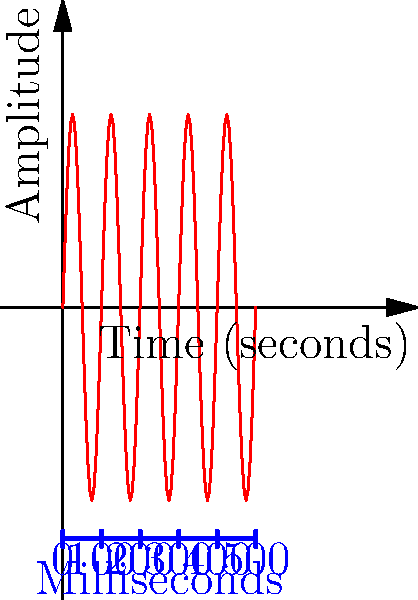As a DJ, you're analyzing a waveform of a new Drake track for your next block party mix. The waveform above represents a 0.5-second snippet of the song. If you count 5 complete cycles in this waveform, what is the beat-per-minute (BPM) of the song? Let's break this down step-by-step:

1) First, we need to calculate the frequency of the waveform:
   - We see 5 complete cycles in 0.5 seconds
   - Frequency = Number of cycles / Time
   - Frequency = 5 / 0.5 = 10 Hz

2) Now, we need to convert this frequency to beats per minute:
   - 1 Hz = 60 BPM (because there are 60 seconds in a minute)
   - So, 10 Hz = 10 * 60 = 600 BPM

3) However, in music production, it's common to consider each peak as a "beat", rather than a complete cycle. In this case:
   - Number of beats = Number of cycles * 2
   - 5 cycles * 2 = 10 beats in 0.5 seconds

4) Let's calculate the BPM based on this:
   - In 0.5 seconds, we have 10 beats
   - In 1 second, we would have 20 beats
   - In 60 seconds (1 minute), we would have 20 * 60 = 1200 beats

Therefore, the BPM of the song is 1200.
Answer: 1200 BPM 